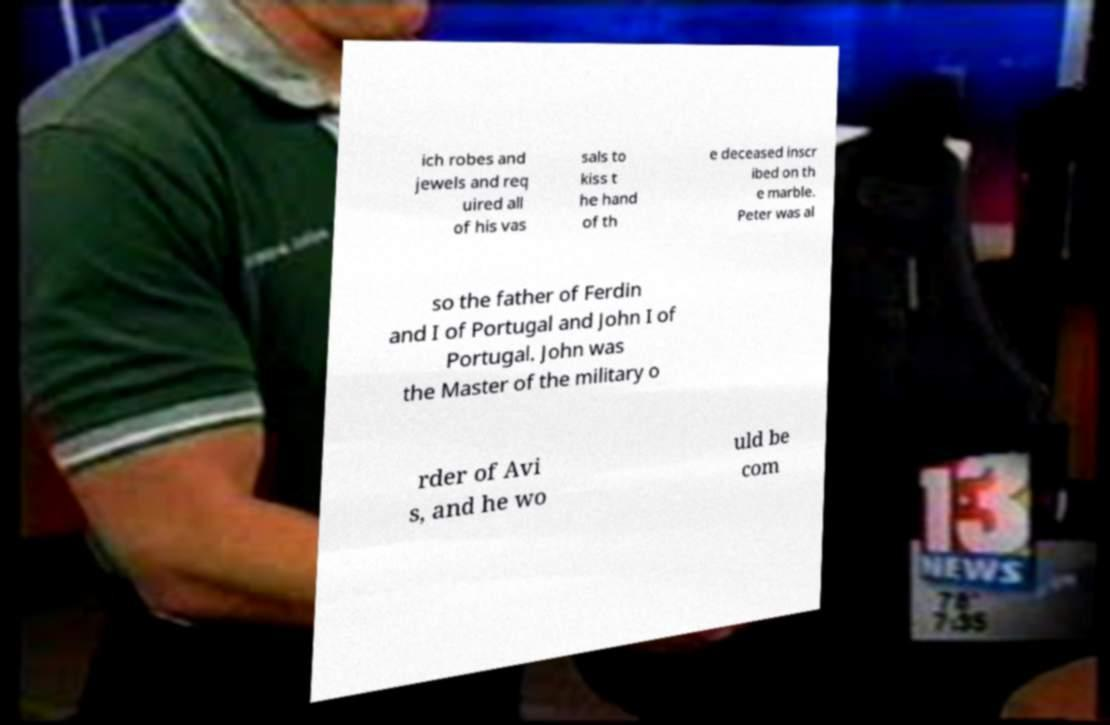There's text embedded in this image that I need extracted. Can you transcribe it verbatim? ich robes and jewels and req uired all of his vas sals to kiss t he hand of th e deceased inscr ibed on th e marble. Peter was al so the father of Ferdin and I of Portugal and John I of Portugal. John was the Master of the military o rder of Avi s, and he wo uld be com 